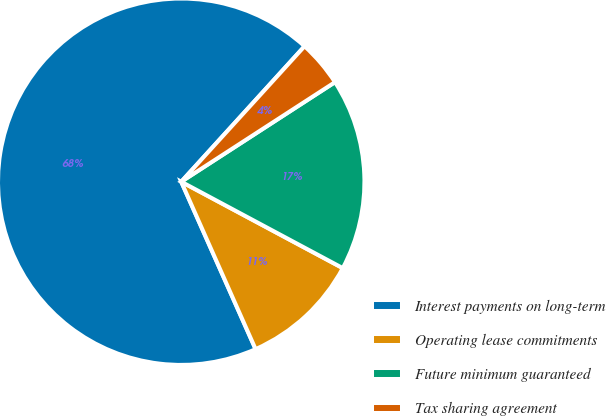Convert chart. <chart><loc_0><loc_0><loc_500><loc_500><pie_chart><fcel>Interest payments on long-term<fcel>Operating lease commitments<fcel>Future minimum guaranteed<fcel>Tax sharing agreement<nl><fcel>68.4%<fcel>10.53%<fcel>16.96%<fcel>4.1%<nl></chart> 